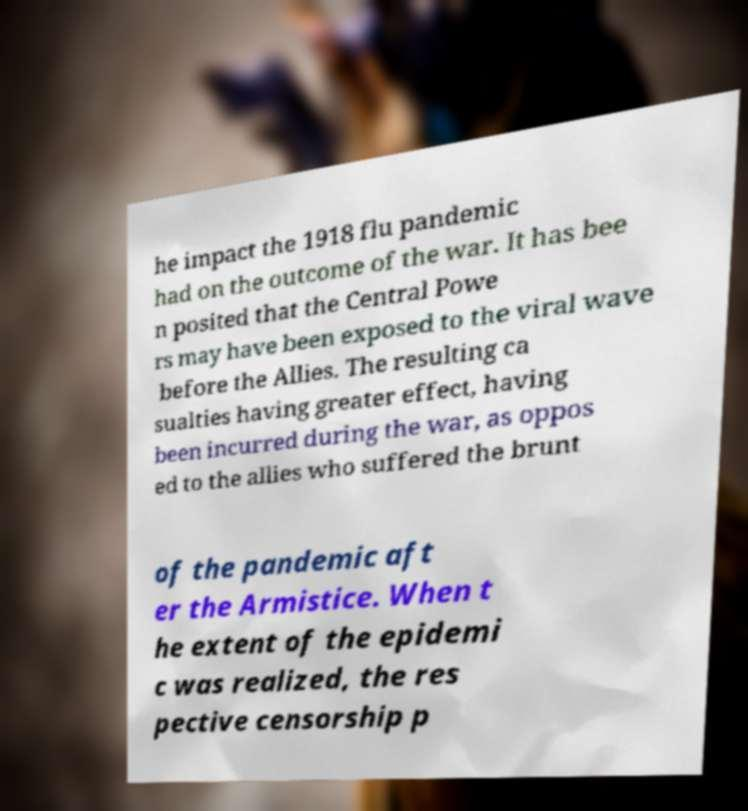Please identify and transcribe the text found in this image. he impact the 1918 flu pandemic had on the outcome of the war. It has bee n posited that the Central Powe rs may have been exposed to the viral wave before the Allies. The resulting ca sualties having greater effect, having been incurred during the war, as oppos ed to the allies who suffered the brunt of the pandemic aft er the Armistice. When t he extent of the epidemi c was realized, the res pective censorship p 